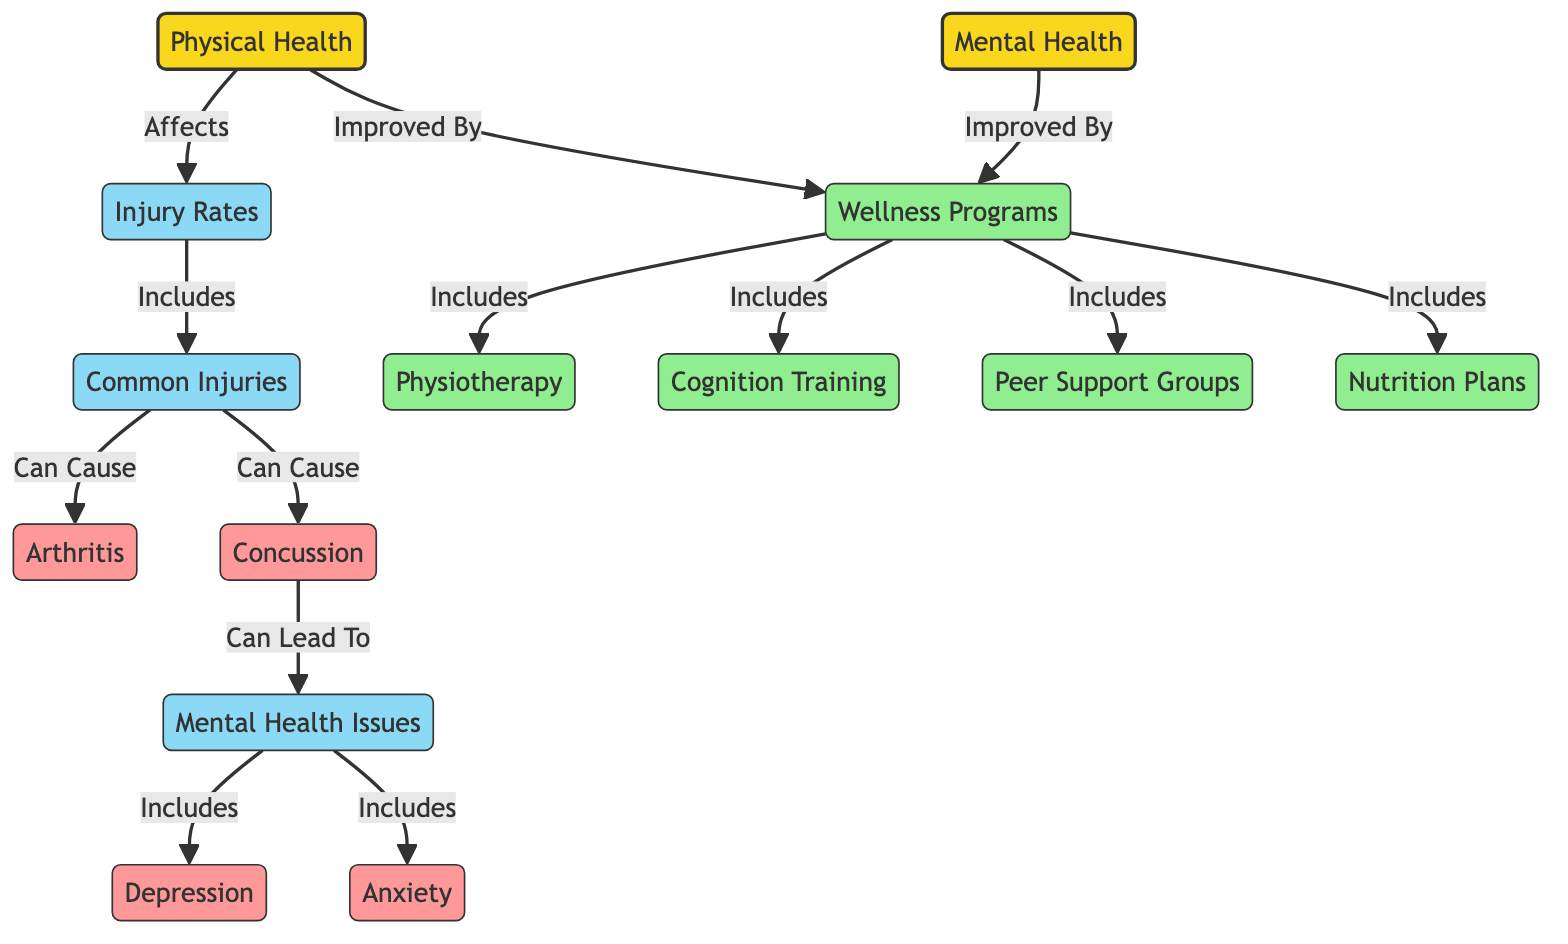What are the main categories of health indicated in the diagram? The diagram indicates two main categories of health: Physical Health and Mental Health. These are the two primary nodes at the top of the diagram.
Answer: Physical Health, Mental Health How many common injuries are listed in the diagram? The diagram indicates one common injuries node, which branches out into two specific injuries: arthritis and concussion. Therefore, there are two common injuries listed.
Answer: 2 What health issue can result from concussions according to the diagram? The diagram shows a direct relationship where concussions can lead to mental health issues, indicating that they are related. Specifically, the node of mental health issues is connected to concussion.
Answer: Mental Health Issues Which wellness program is related to peer support? The diagram lists peer support as a component under the wellness programs node. It shows that peer support is included within the overall wellness strategies available for retired rugby players.
Answer: Peer Support Groups How does physical health improve according to the diagram? The diagram indicates that physical health can be improved by wellness programs. A direct connection exists showing that wellness programs contribute positively to physical health.
Answer: Wellness Programs What are the mental health issues identified in the diagram? The diagram connects mental health issues to two specific conditions: depression and anxiety. Therefore, these two conditions are identified as mental health issues represented in the diagram.
Answer: Depression, Anxiety What can arthritis be caused by in the context of the diagram? The diagram shows a direct relationship where common injuries can cause arthritis, indicating that arthritis is an outcome related to certain injuries sustained while playing rugby.
Answer: Common Injuries How are wellness programs related to both physical and mental health improvements? The diagram indicates that wellness programs improve both physical health and mental health. There are directed arrows from the wellness programs node leading to both physical health and mental health nodes, showing a consistent relationship of improvement through wellness approaches.
Answer: Wellness Programs 